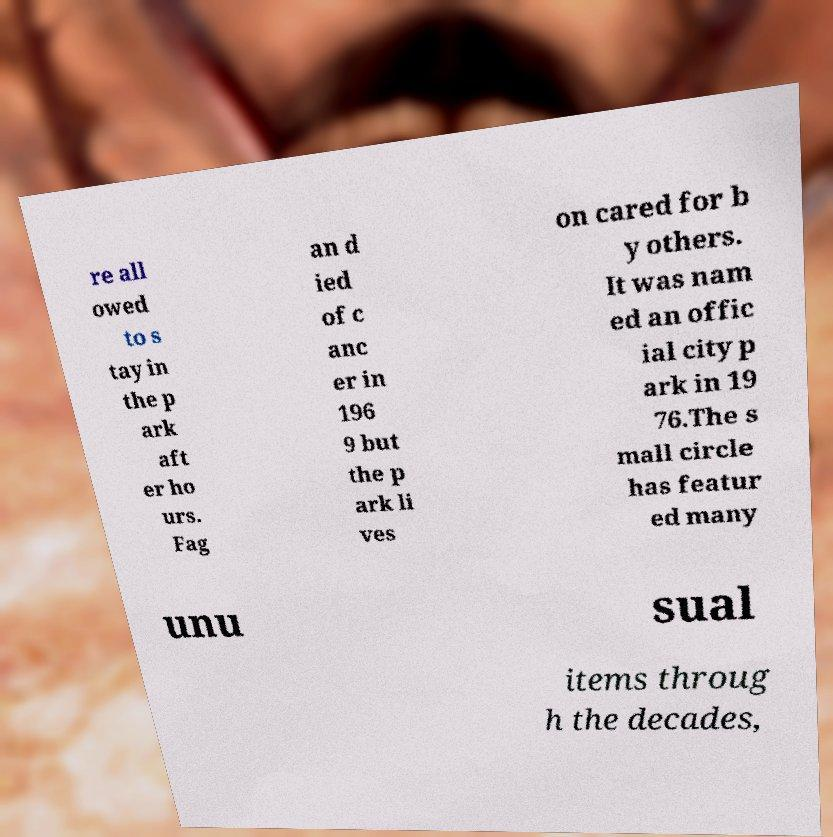Please identify and transcribe the text found in this image. re all owed to s tay in the p ark aft er ho urs. Fag an d ied of c anc er in 196 9 but the p ark li ves on cared for b y others. It was nam ed an offic ial city p ark in 19 76.The s mall circle has featur ed many unu sual items throug h the decades, 